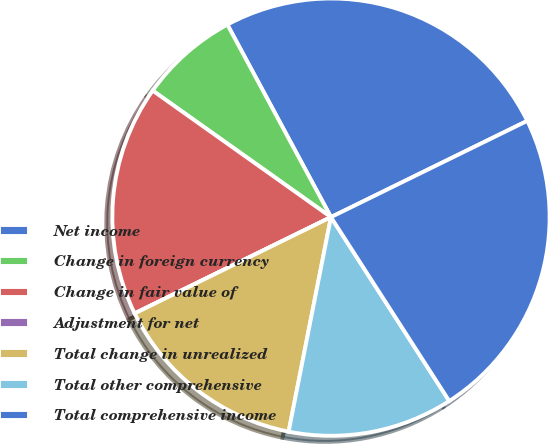Convert chart to OTSL. <chart><loc_0><loc_0><loc_500><loc_500><pie_chart><fcel>Net income<fcel>Change in foreign currency<fcel>Change in fair value of<fcel>Adjustment for net<fcel>Total change in unrealized<fcel>Total other comprehensive<fcel>Total comprehensive income<nl><fcel>25.6%<fcel>7.32%<fcel>17.08%<fcel>0.0%<fcel>14.64%<fcel>12.2%<fcel>23.16%<nl></chart> 